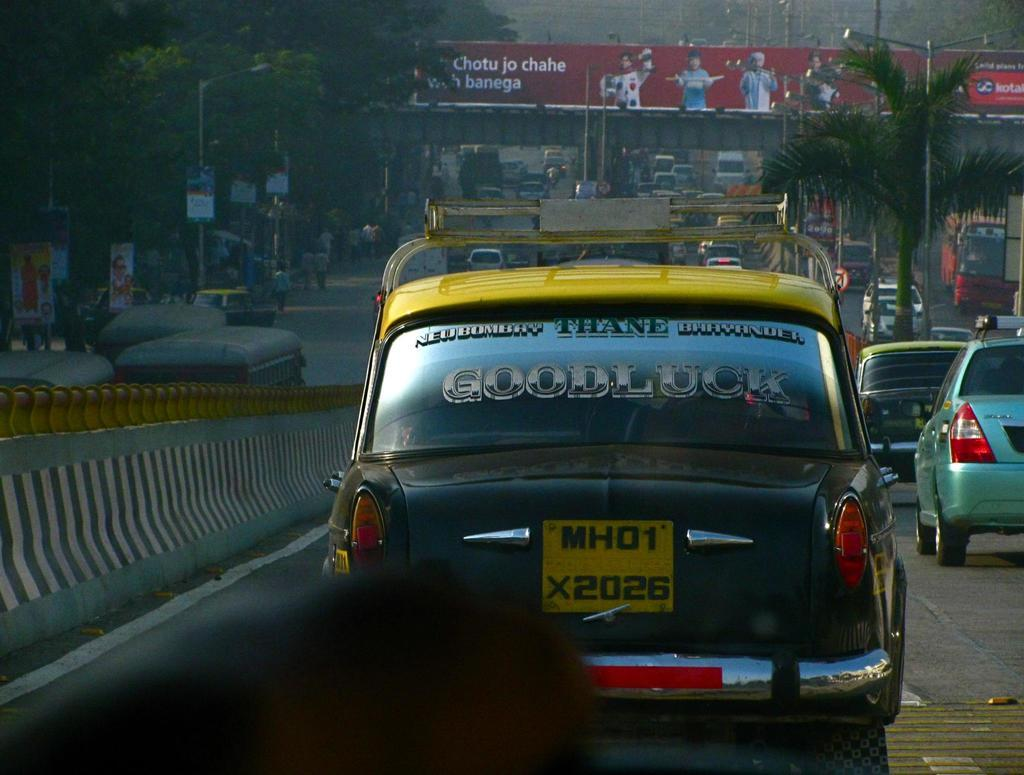<image>
Render a clear and concise summary of the photo. Cars lined up in traffic, older foreign cars one that says Good luck on the rear window. 